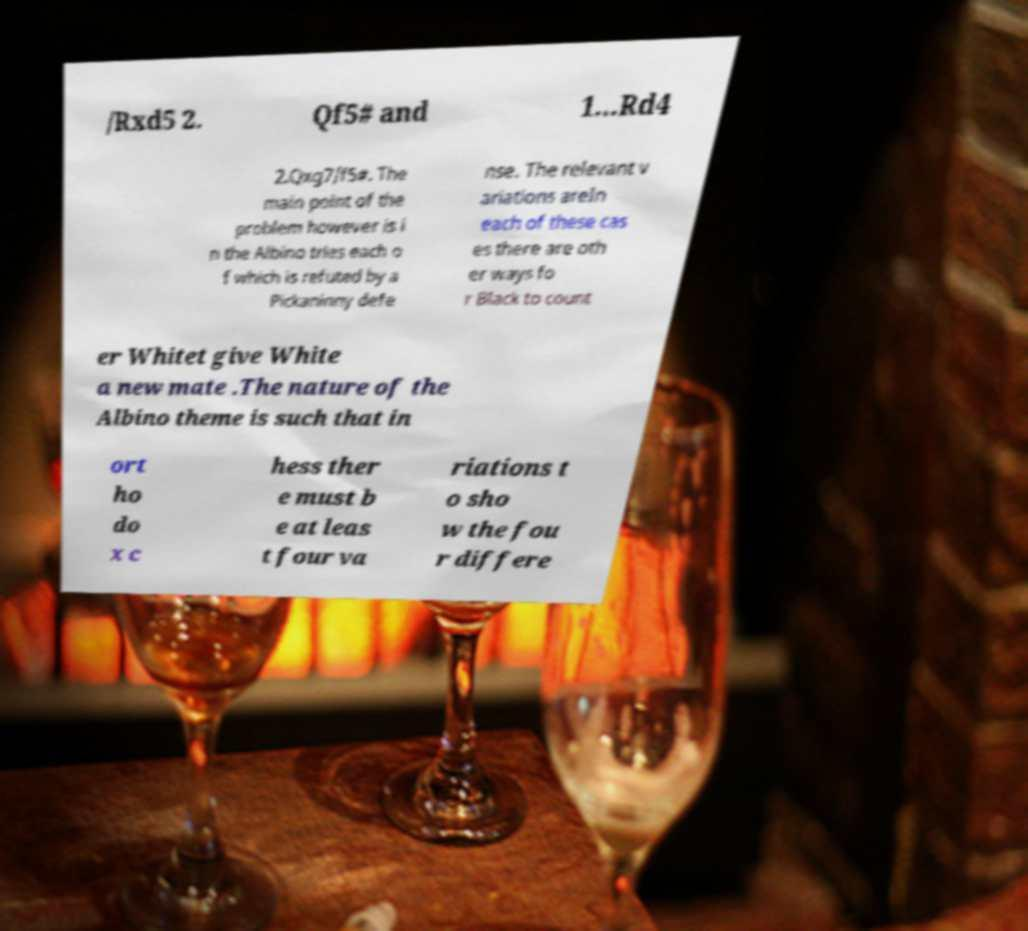Could you assist in decoding the text presented in this image and type it out clearly? /Rxd5 2. Qf5# and 1...Rd4 2.Qxg7/f5#. The main point of the problem however is i n the Albino tries each o f which is refuted by a Pickaninny defe nse. The relevant v ariations areIn each of these cas es there are oth er ways fo r Black to count er Whitet give White a new mate .The nature of the Albino theme is such that in ort ho do x c hess ther e must b e at leas t four va riations t o sho w the fou r differe 